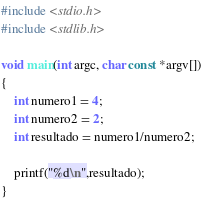<code> <loc_0><loc_0><loc_500><loc_500><_C_>#include <stdio.h>
#include <stdlib.h>

void main(int argc, char const *argv[])
{
    int numero1 = 4;
    int numero2 = 2;
    int resultado = numero1/numero2;

    printf("%d\n",resultado);
}</code> 